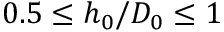Convert formula to latex. <formula><loc_0><loc_0><loc_500><loc_500>0 . 5 \leq h _ { 0 } / D _ { 0 } \leq 1</formula> 